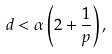Convert formula to latex. <formula><loc_0><loc_0><loc_500><loc_500>d < \alpha \left ( 2 + \frac { 1 } { p } \right ) ,</formula> 